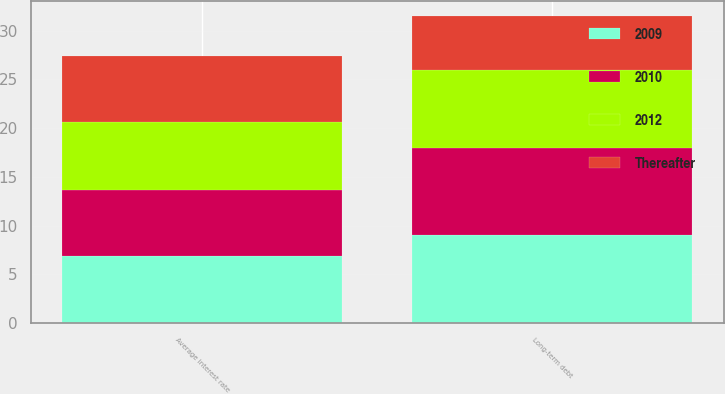<chart> <loc_0><loc_0><loc_500><loc_500><stacked_bar_chart><ecel><fcel>Long-term debt<fcel>Average interest rate<nl><fcel>2009<fcel>9<fcel>6.84<nl><fcel>2012<fcel>8<fcel>6.9<nl><fcel>2010<fcel>9<fcel>6.85<nl><fcel>Thereafter<fcel>5.5<fcel>6.8<nl></chart> 